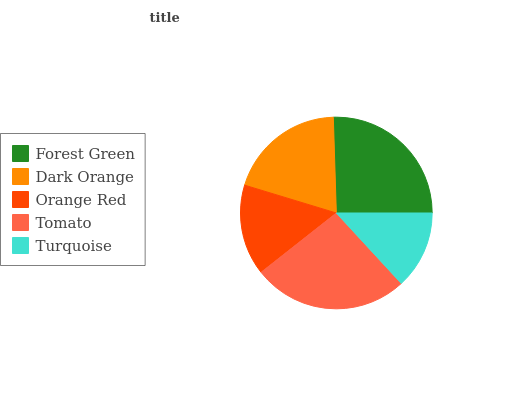Is Turquoise the minimum?
Answer yes or no. Yes. Is Tomato the maximum?
Answer yes or no. Yes. Is Dark Orange the minimum?
Answer yes or no. No. Is Dark Orange the maximum?
Answer yes or no. No. Is Forest Green greater than Dark Orange?
Answer yes or no. Yes. Is Dark Orange less than Forest Green?
Answer yes or no. Yes. Is Dark Orange greater than Forest Green?
Answer yes or no. No. Is Forest Green less than Dark Orange?
Answer yes or no. No. Is Dark Orange the high median?
Answer yes or no. Yes. Is Dark Orange the low median?
Answer yes or no. Yes. Is Orange Red the high median?
Answer yes or no. No. Is Orange Red the low median?
Answer yes or no. No. 